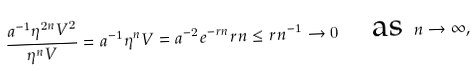Convert formula to latex. <formula><loc_0><loc_0><loc_500><loc_500>\frac { a ^ { - 1 } \eta ^ { 2 n } V ^ { 2 } } { \eta ^ { n } V } = a ^ { - 1 } \eta ^ { n } V = a ^ { - 2 } e ^ { - r n } r n \leq r n ^ { - 1 } \to 0 \quad \text {as } \, n \to \infty ,</formula> 